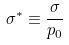Convert formula to latex. <formula><loc_0><loc_0><loc_500><loc_500>\sigma ^ { * } \equiv \frac { \sigma } { p _ { 0 } }</formula> 